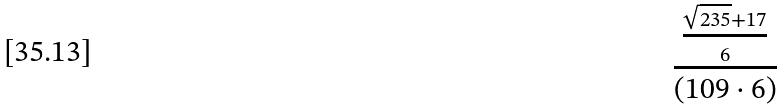<formula> <loc_0><loc_0><loc_500><loc_500>\frac { \frac { \sqrt { 2 3 5 } + 1 7 } { 6 } } { ( 1 0 9 \cdot 6 ) }</formula> 